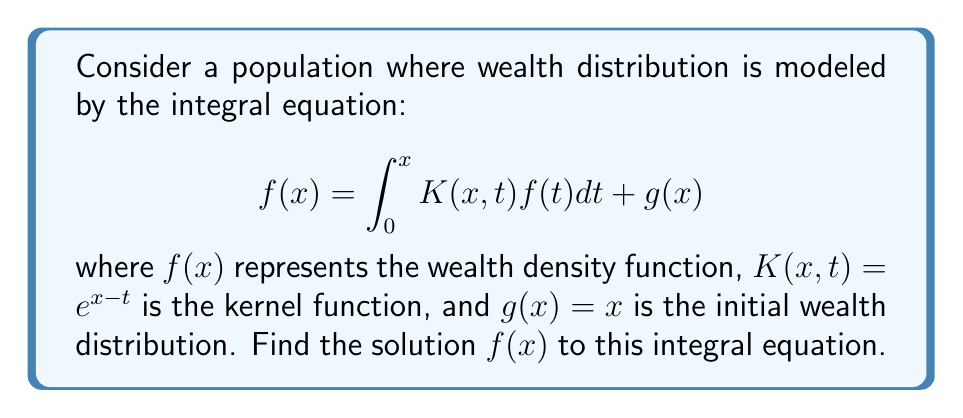Teach me how to tackle this problem. To solve this integral equation, we'll follow these steps:

1) First, we differentiate both sides of the equation with respect to x:

   $$f'(x) = K(x,x)f(x) + \int_0^x \frac{\partial K(x,t)}{\partial x}f(t)dt + g'(x)$$

2) Substituting the given functions:

   $$f'(x) = e^{x-x}f(x) + \int_0^x e^{x-t}f(t)dt + 1$$

   $$f'(x) = f(x) + \int_0^x e^{x-t}f(t)dt + 1$$

3) Differentiate again:

   $$f''(x) = f'(x) + e^{x-x}f(x) + \int_0^x e^{x-t}f(t)dt$$

   $$f''(x) = f'(x) + f(x) + \int_0^x e^{x-t}f(t)dt$$

4) From step 2, we can substitute the integral:

   $$f''(x) = f'(x) + f(x) + (f'(x) - f(x) - 1)$$

   $$f''(x) = 2f'(x) - 1$$

5) This is a second-order linear differential equation. We can solve it:

   Let $y = f'(x)$, then $y' = f''(x)$

   $$y' = 2y - 1$$

   This is a first-order linear equation. The general solution is:

   $$y = Ce^{2x} + \frac{1}{2}$$

6) Integrating back:

   $$f(x) = \int y dx = \frac{C}{2}e^{2x} + \frac{1}{2}x + D$$

7) To find C and D, we use the initial conditions:

   At $x = 0$, $f(0) = g(0) = 0$, so $D = -\frac{C}{2}$

   Substituting back into the original equation:

   $$\frac{C}{2}e^{2x} + \frac{1}{2}x - \frac{C}{2} = \int_0^x e^{x-t}(\frac{C}{2}e^{2t} + \frac{1}{2}t - \frac{C}{2})dt + x$$

8) Solving this equation, we find that $C = 1$

Therefore, the final solution is:

$$f(x) = \frac{1}{2}e^{2x} + \frac{1}{2}x - \frac{1}{2}$$
Answer: $f(x) = \frac{1}{2}e^{2x} + \frac{1}{2}x - \frac{1}{2}$ 